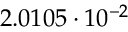Convert formula to latex. <formula><loc_0><loc_0><loc_500><loc_500>2 . 0 1 0 5 \cdot 1 0 ^ { - 2 }</formula> 